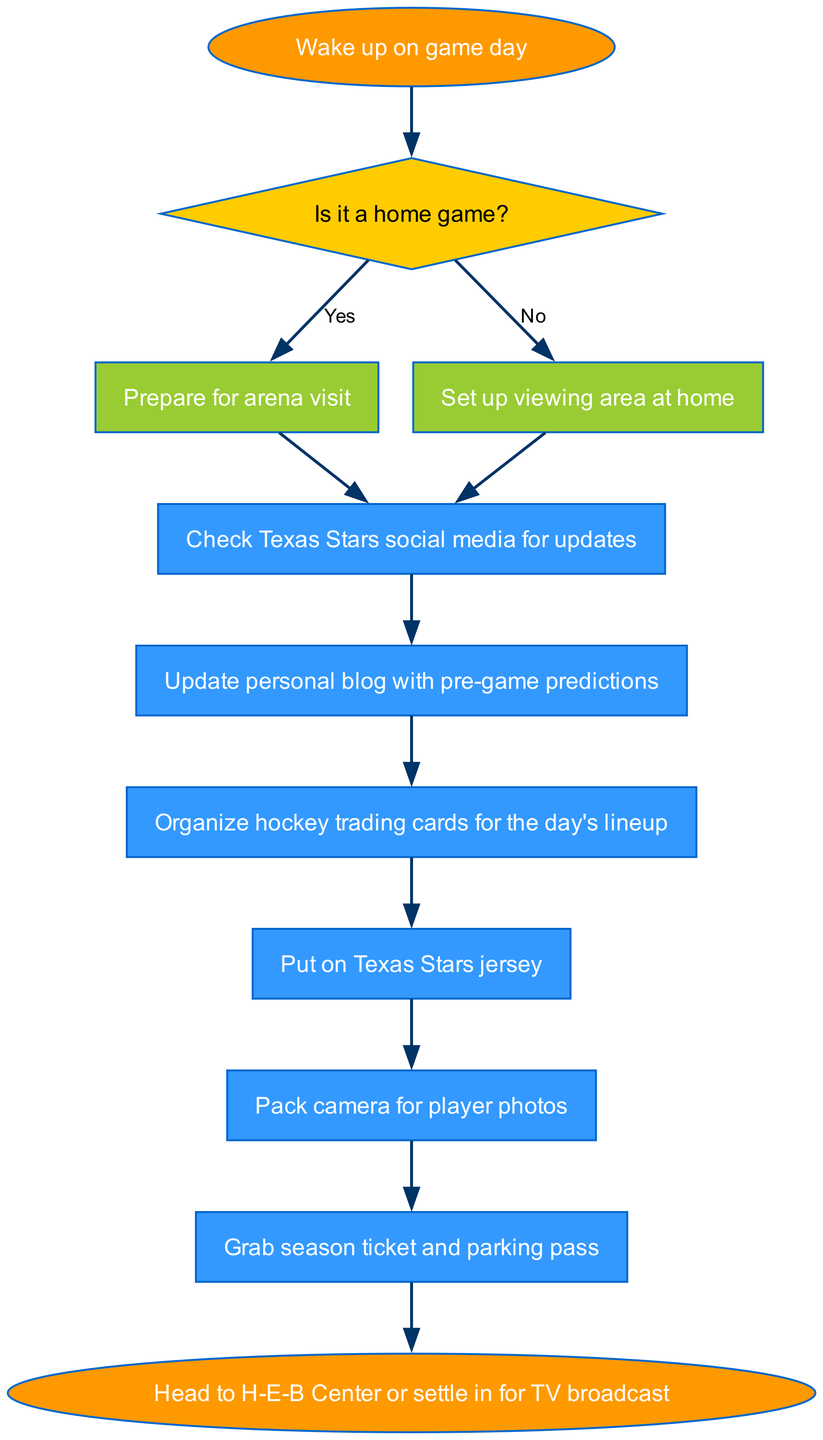What is the starting point of the diagram? The starting point is indicated by the 'start' node, which states "Wake up on game day." This is the first action that begins the routine.
Answer: Wake up on game day How many action nodes are present in the diagram? There are 6 action nodes sequentially laid out after the decision node, starting from "Check Texas Stars social media for updates" to "Grab season ticket and parking pass."
Answer: 6 What does the diagram suggest a fan should check first? The first action after the decision node is "Check Texas Stars social media for updates," indicating that this is the first thing a fan should do.
Answer: Check Texas Stars social media for updates What happens if it's not a home game? If it is not a home game, the diagram directs to "Set up viewing area at home," which is an alternative action to attending the game in person.
Answer: Set up viewing area at home What is the final action before heading to the arena or settling in? The last action listed before reaching the end node is "Grab season ticket and parking pass," which is instrumental for entrance to the game.
Answer: Grab season ticket and parking pass Which action node directly follows preparing for the arena visit? The second action that follows "Prepare for arena visit" is "Check Texas Stars social media for updates," which is a crucial first step.
Answer: Check Texas Stars social media for updates What color represents the decision nodes in the diagram? The decision node specified in the diagram is filled with a yellow color, as indicated by the notation for decision nodes.
Answer: Yellow How many edges emanate from the decision node? The decision node has two edges branching out - one labeled 'Yes' leading to "Prepare for arena visit" and another labeled 'No' leading to "Set up viewing area at home."
Answer: 2 